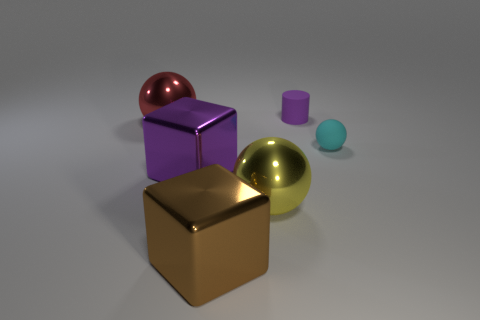How many objects are large brown things on the left side of the small purple matte thing or gray blocks?
Offer a very short reply. 1. Is the material of the big brown thing the same as the ball that is right of the small purple rubber cylinder?
Ensure brevity in your answer.  No. What number of other things are the same shape as the red metal thing?
Offer a terse response. 2. What number of objects are either things that are behind the big red object or rubber objects on the right side of the purple matte cylinder?
Keep it short and to the point. 2. What number of other things are there of the same color as the tiny rubber cylinder?
Ensure brevity in your answer.  1. Is the number of cyan balls on the left side of the purple block less than the number of objects in front of the red sphere?
Provide a succinct answer. Yes. How many small yellow matte cylinders are there?
Ensure brevity in your answer.  0. There is a big yellow object that is the same shape as the big red shiny thing; what material is it?
Your answer should be very brief. Metal. Is the number of big brown metal cubes that are to the right of the large brown object less than the number of large yellow shiny objects?
Make the answer very short. Yes. There is a cyan matte object that is behind the brown metal thing; is it the same shape as the red object?
Make the answer very short. Yes. 